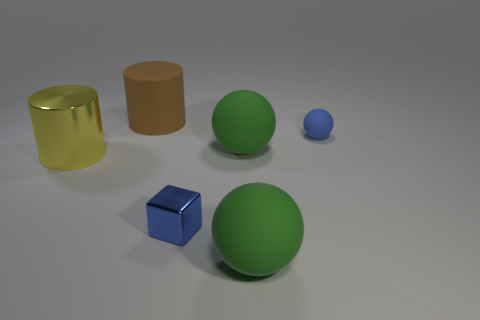What can you infer about the size relationships among the objects? The relationships suggest a variety of sizes, with the two spheres being of different diameters, the larger green one being the most prominent. The blue cube and the small blue sphere appear similar in size, possibly indicating that they relate to each other in terms of scale. The cylinders seem to be of comparable height but differ in thickness. 